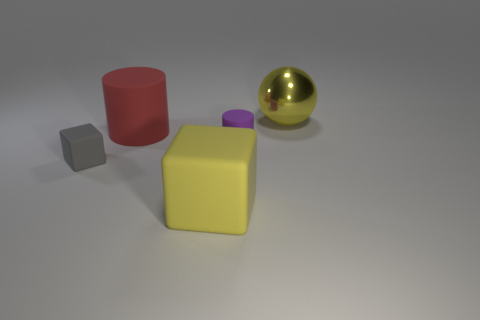How many other objects are the same size as the yellow metallic ball?
Your response must be concise. 2. Are there any cubes of the same size as the yellow sphere?
Give a very brief answer. Yes. There is a small matte thing that is in front of the small cylinder; does it have the same color as the big matte cylinder?
Provide a short and direct response. No. What number of things are either green metal blocks or rubber cylinders?
Your answer should be very brief. 2. Does the yellow thing behind the red cylinder have the same size as the tiny matte block?
Provide a succinct answer. No. What is the size of the matte thing that is both behind the gray matte thing and in front of the red object?
Offer a very short reply. Small. How many other objects are there of the same shape as the tiny purple object?
Offer a very short reply. 1. What number of other objects are there of the same material as the small cylinder?
Give a very brief answer. 3. What is the size of the purple object that is the same shape as the red object?
Provide a short and direct response. Small. Is the ball the same color as the tiny cube?
Your answer should be very brief. No. 